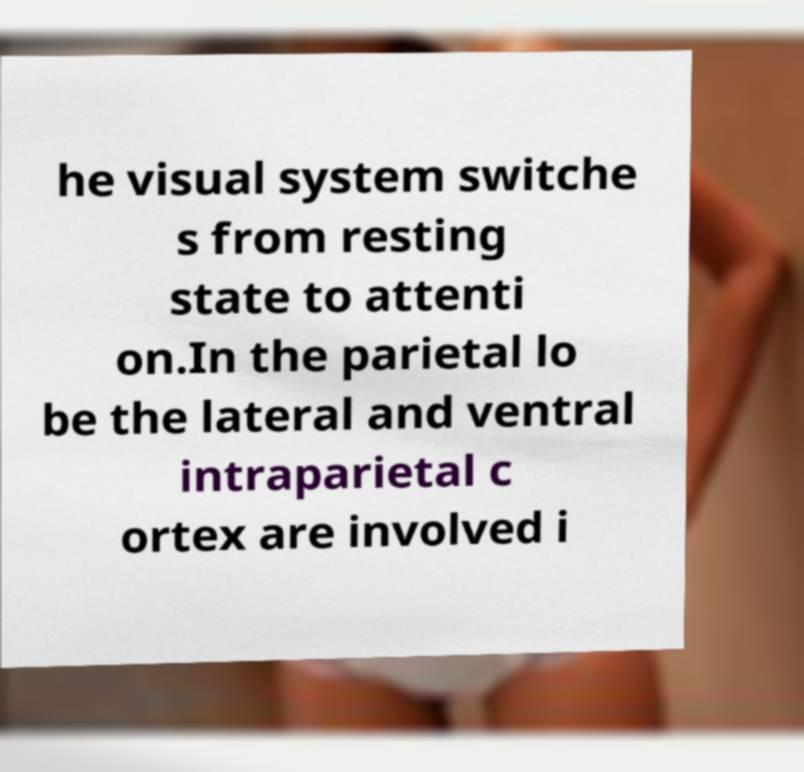Can you accurately transcribe the text from the provided image for me? he visual system switche s from resting state to attenti on.In the parietal lo be the lateral and ventral intraparietal c ortex are involved i 